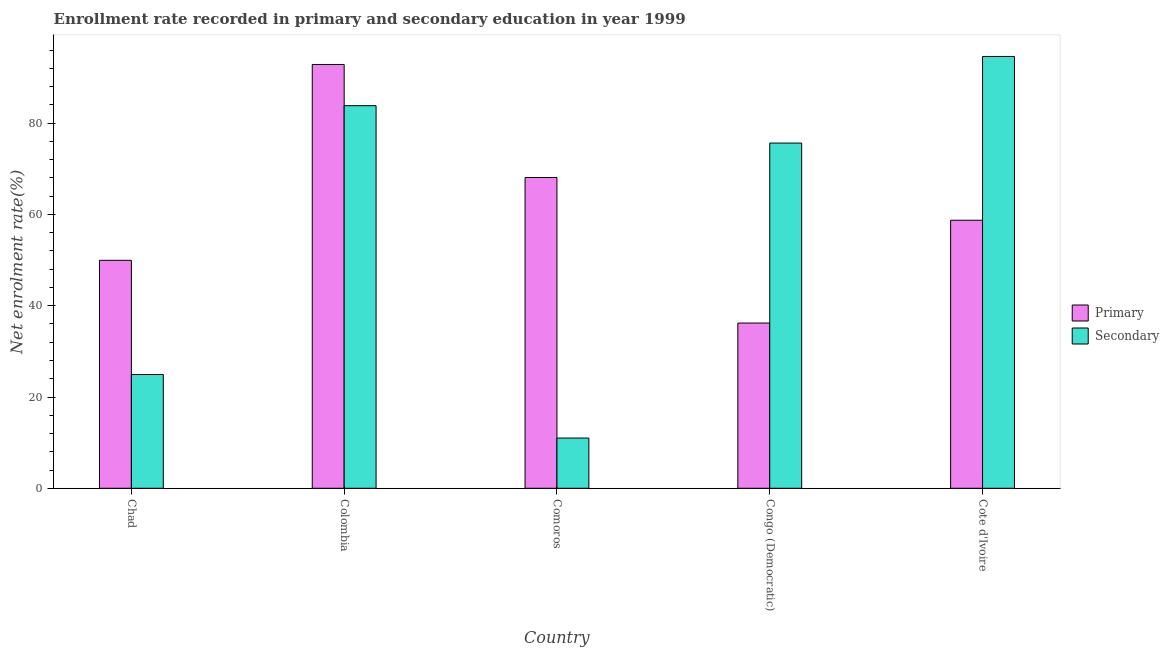How many groups of bars are there?
Your answer should be very brief. 5. Are the number of bars per tick equal to the number of legend labels?
Offer a terse response. Yes. How many bars are there on the 5th tick from the left?
Your answer should be very brief. 2. How many bars are there on the 3rd tick from the right?
Your answer should be very brief. 2. What is the label of the 4th group of bars from the left?
Make the answer very short. Congo (Democratic). In how many cases, is the number of bars for a given country not equal to the number of legend labels?
Ensure brevity in your answer.  0. What is the enrollment rate in primary education in Cote d'Ivoire?
Your response must be concise. 58.74. Across all countries, what is the maximum enrollment rate in secondary education?
Your answer should be compact. 94.63. Across all countries, what is the minimum enrollment rate in secondary education?
Your response must be concise. 11.01. In which country was the enrollment rate in secondary education maximum?
Make the answer very short. Cote d'Ivoire. In which country was the enrollment rate in primary education minimum?
Keep it short and to the point. Congo (Democratic). What is the total enrollment rate in secondary education in the graph?
Your answer should be very brief. 290.06. What is the difference between the enrollment rate in primary education in Chad and that in Colombia?
Give a very brief answer. -42.91. What is the difference between the enrollment rate in secondary education in Chad and the enrollment rate in primary education in Cote d'Ivoire?
Offer a very short reply. -33.81. What is the average enrollment rate in secondary education per country?
Offer a very short reply. 58.01. What is the difference between the enrollment rate in primary education and enrollment rate in secondary education in Congo (Democratic)?
Offer a very short reply. -39.44. What is the ratio of the enrollment rate in primary education in Chad to that in Cote d'Ivoire?
Your answer should be very brief. 0.85. Is the enrollment rate in secondary education in Colombia less than that in Comoros?
Ensure brevity in your answer.  No. Is the difference between the enrollment rate in primary education in Comoros and Cote d'Ivoire greater than the difference between the enrollment rate in secondary education in Comoros and Cote d'Ivoire?
Provide a short and direct response. Yes. What is the difference between the highest and the second highest enrollment rate in secondary education?
Ensure brevity in your answer.  10.78. What is the difference between the highest and the lowest enrollment rate in secondary education?
Provide a short and direct response. 83.62. In how many countries, is the enrollment rate in secondary education greater than the average enrollment rate in secondary education taken over all countries?
Your answer should be compact. 3. Is the sum of the enrollment rate in secondary education in Colombia and Cote d'Ivoire greater than the maximum enrollment rate in primary education across all countries?
Your answer should be very brief. Yes. What does the 2nd bar from the left in Comoros represents?
Offer a very short reply. Secondary. What does the 1st bar from the right in Colombia represents?
Ensure brevity in your answer.  Secondary. How many bars are there?
Give a very brief answer. 10. Are the values on the major ticks of Y-axis written in scientific E-notation?
Offer a terse response. No. Does the graph contain any zero values?
Your response must be concise. No. Where does the legend appear in the graph?
Your answer should be very brief. Center right. How many legend labels are there?
Provide a short and direct response. 2. What is the title of the graph?
Provide a succinct answer. Enrollment rate recorded in primary and secondary education in year 1999. Does "Study and work" appear as one of the legend labels in the graph?
Ensure brevity in your answer.  No. What is the label or title of the Y-axis?
Ensure brevity in your answer.  Net enrolment rate(%). What is the Net enrolment rate(%) in Primary in Chad?
Keep it short and to the point. 49.95. What is the Net enrolment rate(%) of Secondary in Chad?
Your answer should be very brief. 24.93. What is the Net enrolment rate(%) in Primary in Colombia?
Keep it short and to the point. 92.86. What is the Net enrolment rate(%) in Secondary in Colombia?
Give a very brief answer. 83.84. What is the Net enrolment rate(%) of Primary in Comoros?
Provide a short and direct response. 68.1. What is the Net enrolment rate(%) of Secondary in Comoros?
Your answer should be very brief. 11.01. What is the Net enrolment rate(%) in Primary in Congo (Democratic)?
Offer a terse response. 36.21. What is the Net enrolment rate(%) in Secondary in Congo (Democratic)?
Offer a terse response. 75.65. What is the Net enrolment rate(%) of Primary in Cote d'Ivoire?
Make the answer very short. 58.74. What is the Net enrolment rate(%) in Secondary in Cote d'Ivoire?
Your answer should be very brief. 94.63. Across all countries, what is the maximum Net enrolment rate(%) of Primary?
Give a very brief answer. 92.86. Across all countries, what is the maximum Net enrolment rate(%) in Secondary?
Provide a short and direct response. 94.63. Across all countries, what is the minimum Net enrolment rate(%) in Primary?
Keep it short and to the point. 36.21. Across all countries, what is the minimum Net enrolment rate(%) of Secondary?
Keep it short and to the point. 11.01. What is the total Net enrolment rate(%) of Primary in the graph?
Provide a succinct answer. 305.87. What is the total Net enrolment rate(%) in Secondary in the graph?
Your answer should be very brief. 290.06. What is the difference between the Net enrolment rate(%) of Primary in Chad and that in Colombia?
Keep it short and to the point. -42.91. What is the difference between the Net enrolment rate(%) of Secondary in Chad and that in Colombia?
Ensure brevity in your answer.  -58.91. What is the difference between the Net enrolment rate(%) in Primary in Chad and that in Comoros?
Make the answer very short. -18.15. What is the difference between the Net enrolment rate(%) of Secondary in Chad and that in Comoros?
Your answer should be compact. 13.92. What is the difference between the Net enrolment rate(%) of Primary in Chad and that in Congo (Democratic)?
Offer a terse response. 13.74. What is the difference between the Net enrolment rate(%) of Secondary in Chad and that in Congo (Democratic)?
Give a very brief answer. -50.72. What is the difference between the Net enrolment rate(%) in Primary in Chad and that in Cote d'Ivoire?
Make the answer very short. -8.78. What is the difference between the Net enrolment rate(%) of Secondary in Chad and that in Cote d'Ivoire?
Provide a short and direct response. -69.7. What is the difference between the Net enrolment rate(%) in Primary in Colombia and that in Comoros?
Provide a short and direct response. 24.76. What is the difference between the Net enrolment rate(%) of Secondary in Colombia and that in Comoros?
Keep it short and to the point. 72.83. What is the difference between the Net enrolment rate(%) in Primary in Colombia and that in Congo (Democratic)?
Provide a short and direct response. 56.65. What is the difference between the Net enrolment rate(%) in Secondary in Colombia and that in Congo (Democratic)?
Your answer should be very brief. 8.19. What is the difference between the Net enrolment rate(%) in Primary in Colombia and that in Cote d'Ivoire?
Your answer should be very brief. 34.12. What is the difference between the Net enrolment rate(%) in Secondary in Colombia and that in Cote d'Ivoire?
Make the answer very short. -10.78. What is the difference between the Net enrolment rate(%) of Primary in Comoros and that in Congo (Democratic)?
Ensure brevity in your answer.  31.89. What is the difference between the Net enrolment rate(%) in Secondary in Comoros and that in Congo (Democratic)?
Your response must be concise. -64.64. What is the difference between the Net enrolment rate(%) in Primary in Comoros and that in Cote d'Ivoire?
Your answer should be compact. 9.36. What is the difference between the Net enrolment rate(%) in Secondary in Comoros and that in Cote d'Ivoire?
Your response must be concise. -83.62. What is the difference between the Net enrolment rate(%) of Primary in Congo (Democratic) and that in Cote d'Ivoire?
Make the answer very short. -22.53. What is the difference between the Net enrolment rate(%) in Secondary in Congo (Democratic) and that in Cote d'Ivoire?
Offer a very short reply. -18.98. What is the difference between the Net enrolment rate(%) in Primary in Chad and the Net enrolment rate(%) in Secondary in Colombia?
Your answer should be compact. -33.89. What is the difference between the Net enrolment rate(%) of Primary in Chad and the Net enrolment rate(%) of Secondary in Comoros?
Your response must be concise. 38.95. What is the difference between the Net enrolment rate(%) of Primary in Chad and the Net enrolment rate(%) of Secondary in Congo (Democratic)?
Provide a succinct answer. -25.7. What is the difference between the Net enrolment rate(%) of Primary in Chad and the Net enrolment rate(%) of Secondary in Cote d'Ivoire?
Your answer should be compact. -44.67. What is the difference between the Net enrolment rate(%) of Primary in Colombia and the Net enrolment rate(%) of Secondary in Comoros?
Ensure brevity in your answer.  81.86. What is the difference between the Net enrolment rate(%) of Primary in Colombia and the Net enrolment rate(%) of Secondary in Congo (Democratic)?
Offer a terse response. 17.21. What is the difference between the Net enrolment rate(%) of Primary in Colombia and the Net enrolment rate(%) of Secondary in Cote d'Ivoire?
Provide a short and direct response. -1.76. What is the difference between the Net enrolment rate(%) in Primary in Comoros and the Net enrolment rate(%) in Secondary in Congo (Democratic)?
Your response must be concise. -7.55. What is the difference between the Net enrolment rate(%) of Primary in Comoros and the Net enrolment rate(%) of Secondary in Cote d'Ivoire?
Provide a succinct answer. -26.53. What is the difference between the Net enrolment rate(%) of Primary in Congo (Democratic) and the Net enrolment rate(%) of Secondary in Cote d'Ivoire?
Provide a short and direct response. -58.42. What is the average Net enrolment rate(%) of Primary per country?
Offer a very short reply. 61.17. What is the average Net enrolment rate(%) in Secondary per country?
Your response must be concise. 58.01. What is the difference between the Net enrolment rate(%) of Primary and Net enrolment rate(%) of Secondary in Chad?
Keep it short and to the point. 25.02. What is the difference between the Net enrolment rate(%) in Primary and Net enrolment rate(%) in Secondary in Colombia?
Make the answer very short. 9.02. What is the difference between the Net enrolment rate(%) in Primary and Net enrolment rate(%) in Secondary in Comoros?
Keep it short and to the point. 57.09. What is the difference between the Net enrolment rate(%) of Primary and Net enrolment rate(%) of Secondary in Congo (Democratic)?
Your answer should be very brief. -39.44. What is the difference between the Net enrolment rate(%) in Primary and Net enrolment rate(%) in Secondary in Cote d'Ivoire?
Provide a short and direct response. -35.89. What is the ratio of the Net enrolment rate(%) of Primary in Chad to that in Colombia?
Your answer should be compact. 0.54. What is the ratio of the Net enrolment rate(%) of Secondary in Chad to that in Colombia?
Your answer should be very brief. 0.3. What is the ratio of the Net enrolment rate(%) in Primary in Chad to that in Comoros?
Offer a very short reply. 0.73. What is the ratio of the Net enrolment rate(%) in Secondary in Chad to that in Comoros?
Your answer should be very brief. 2.26. What is the ratio of the Net enrolment rate(%) of Primary in Chad to that in Congo (Democratic)?
Offer a very short reply. 1.38. What is the ratio of the Net enrolment rate(%) of Secondary in Chad to that in Congo (Democratic)?
Ensure brevity in your answer.  0.33. What is the ratio of the Net enrolment rate(%) in Primary in Chad to that in Cote d'Ivoire?
Make the answer very short. 0.85. What is the ratio of the Net enrolment rate(%) in Secondary in Chad to that in Cote d'Ivoire?
Provide a succinct answer. 0.26. What is the ratio of the Net enrolment rate(%) of Primary in Colombia to that in Comoros?
Offer a very short reply. 1.36. What is the ratio of the Net enrolment rate(%) of Secondary in Colombia to that in Comoros?
Offer a very short reply. 7.62. What is the ratio of the Net enrolment rate(%) in Primary in Colombia to that in Congo (Democratic)?
Your answer should be compact. 2.56. What is the ratio of the Net enrolment rate(%) of Secondary in Colombia to that in Congo (Democratic)?
Keep it short and to the point. 1.11. What is the ratio of the Net enrolment rate(%) of Primary in Colombia to that in Cote d'Ivoire?
Keep it short and to the point. 1.58. What is the ratio of the Net enrolment rate(%) of Secondary in Colombia to that in Cote d'Ivoire?
Make the answer very short. 0.89. What is the ratio of the Net enrolment rate(%) in Primary in Comoros to that in Congo (Democratic)?
Make the answer very short. 1.88. What is the ratio of the Net enrolment rate(%) in Secondary in Comoros to that in Congo (Democratic)?
Your answer should be very brief. 0.15. What is the ratio of the Net enrolment rate(%) in Primary in Comoros to that in Cote d'Ivoire?
Give a very brief answer. 1.16. What is the ratio of the Net enrolment rate(%) in Secondary in Comoros to that in Cote d'Ivoire?
Make the answer very short. 0.12. What is the ratio of the Net enrolment rate(%) of Primary in Congo (Democratic) to that in Cote d'Ivoire?
Make the answer very short. 0.62. What is the ratio of the Net enrolment rate(%) of Secondary in Congo (Democratic) to that in Cote d'Ivoire?
Offer a terse response. 0.8. What is the difference between the highest and the second highest Net enrolment rate(%) in Primary?
Give a very brief answer. 24.76. What is the difference between the highest and the second highest Net enrolment rate(%) in Secondary?
Make the answer very short. 10.78. What is the difference between the highest and the lowest Net enrolment rate(%) in Primary?
Offer a very short reply. 56.65. What is the difference between the highest and the lowest Net enrolment rate(%) of Secondary?
Your answer should be compact. 83.62. 